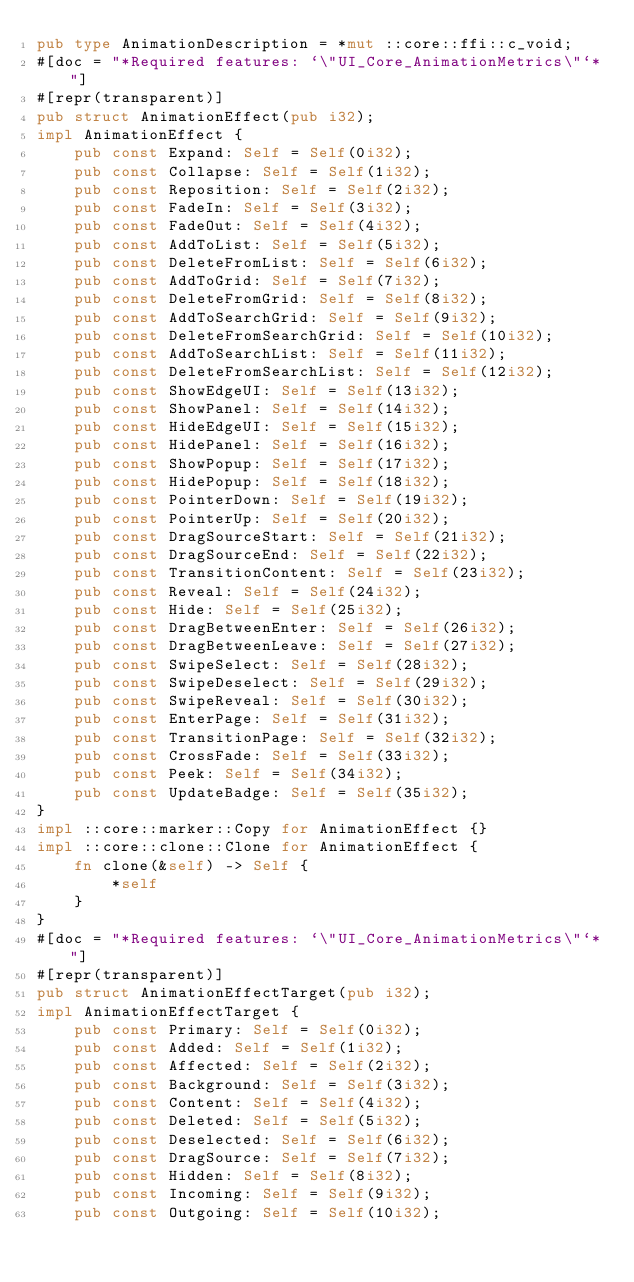Convert code to text. <code><loc_0><loc_0><loc_500><loc_500><_Rust_>pub type AnimationDescription = *mut ::core::ffi::c_void;
#[doc = "*Required features: `\"UI_Core_AnimationMetrics\"`*"]
#[repr(transparent)]
pub struct AnimationEffect(pub i32);
impl AnimationEffect {
    pub const Expand: Self = Self(0i32);
    pub const Collapse: Self = Self(1i32);
    pub const Reposition: Self = Self(2i32);
    pub const FadeIn: Self = Self(3i32);
    pub const FadeOut: Self = Self(4i32);
    pub const AddToList: Self = Self(5i32);
    pub const DeleteFromList: Self = Self(6i32);
    pub const AddToGrid: Self = Self(7i32);
    pub const DeleteFromGrid: Self = Self(8i32);
    pub const AddToSearchGrid: Self = Self(9i32);
    pub const DeleteFromSearchGrid: Self = Self(10i32);
    pub const AddToSearchList: Self = Self(11i32);
    pub const DeleteFromSearchList: Self = Self(12i32);
    pub const ShowEdgeUI: Self = Self(13i32);
    pub const ShowPanel: Self = Self(14i32);
    pub const HideEdgeUI: Self = Self(15i32);
    pub const HidePanel: Self = Self(16i32);
    pub const ShowPopup: Self = Self(17i32);
    pub const HidePopup: Self = Self(18i32);
    pub const PointerDown: Self = Self(19i32);
    pub const PointerUp: Self = Self(20i32);
    pub const DragSourceStart: Self = Self(21i32);
    pub const DragSourceEnd: Self = Self(22i32);
    pub const TransitionContent: Self = Self(23i32);
    pub const Reveal: Self = Self(24i32);
    pub const Hide: Self = Self(25i32);
    pub const DragBetweenEnter: Self = Self(26i32);
    pub const DragBetweenLeave: Self = Self(27i32);
    pub const SwipeSelect: Self = Self(28i32);
    pub const SwipeDeselect: Self = Self(29i32);
    pub const SwipeReveal: Self = Self(30i32);
    pub const EnterPage: Self = Self(31i32);
    pub const TransitionPage: Self = Self(32i32);
    pub const CrossFade: Self = Self(33i32);
    pub const Peek: Self = Self(34i32);
    pub const UpdateBadge: Self = Self(35i32);
}
impl ::core::marker::Copy for AnimationEffect {}
impl ::core::clone::Clone for AnimationEffect {
    fn clone(&self) -> Self {
        *self
    }
}
#[doc = "*Required features: `\"UI_Core_AnimationMetrics\"`*"]
#[repr(transparent)]
pub struct AnimationEffectTarget(pub i32);
impl AnimationEffectTarget {
    pub const Primary: Self = Self(0i32);
    pub const Added: Self = Self(1i32);
    pub const Affected: Self = Self(2i32);
    pub const Background: Self = Self(3i32);
    pub const Content: Self = Self(4i32);
    pub const Deleted: Self = Self(5i32);
    pub const Deselected: Self = Self(6i32);
    pub const DragSource: Self = Self(7i32);
    pub const Hidden: Self = Self(8i32);
    pub const Incoming: Self = Self(9i32);
    pub const Outgoing: Self = Self(10i32);</code> 